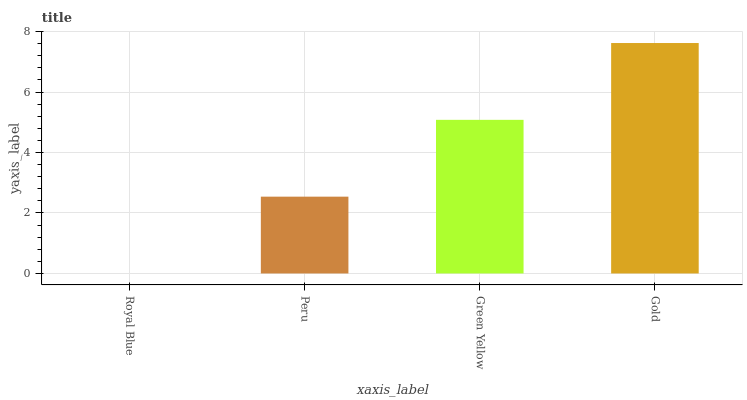Is Royal Blue the minimum?
Answer yes or no. Yes. Is Gold the maximum?
Answer yes or no. Yes. Is Peru the minimum?
Answer yes or no. No. Is Peru the maximum?
Answer yes or no. No. Is Peru greater than Royal Blue?
Answer yes or no. Yes. Is Royal Blue less than Peru?
Answer yes or no. Yes. Is Royal Blue greater than Peru?
Answer yes or no. No. Is Peru less than Royal Blue?
Answer yes or no. No. Is Green Yellow the high median?
Answer yes or no. Yes. Is Peru the low median?
Answer yes or no. Yes. Is Gold the high median?
Answer yes or no. No. Is Gold the low median?
Answer yes or no. No. 